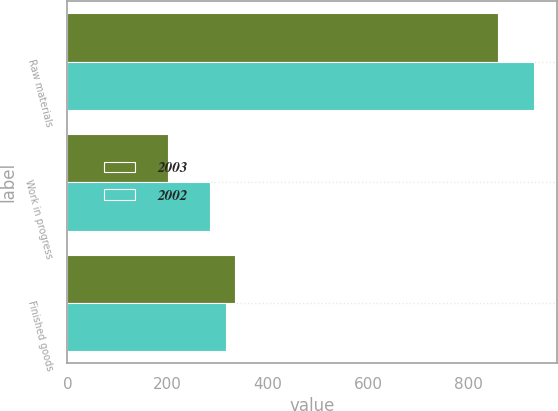<chart> <loc_0><loc_0><loc_500><loc_500><stacked_bar_chart><ecel><fcel>Raw materials<fcel>Work in progress<fcel>Finished goods<nl><fcel>2003<fcel>859<fcel>201<fcel>335<nl><fcel>2002<fcel>931<fcel>285<fcel>317<nl></chart> 